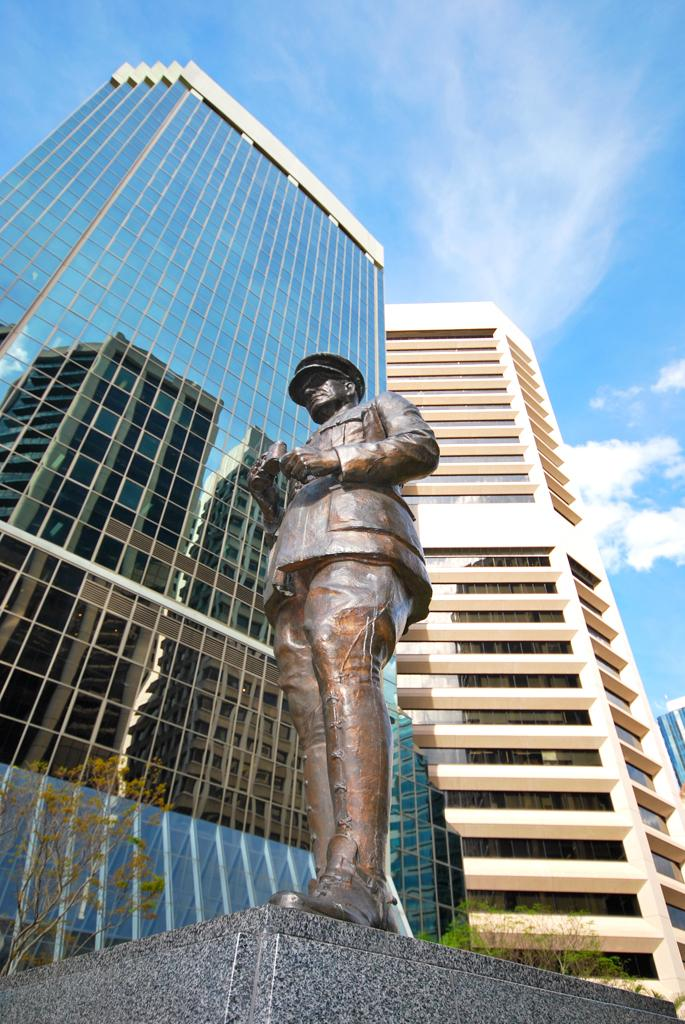What is the main subject of the image? There is a statue in the image. How is the statue positioned in the image? The statue is on a pedestal. What type of natural elements can be seen in the image? There are trees in the image. What type of man-made structures can be seen in the image? There are buildings in the image. What is visible in the background of the image? The sky is visible in the image, and clouds are present in the sky. What grade does the statue receive for its performance in the story depicted in the image? There is no story or performance associated with the statue in the image, so it cannot be graded. 